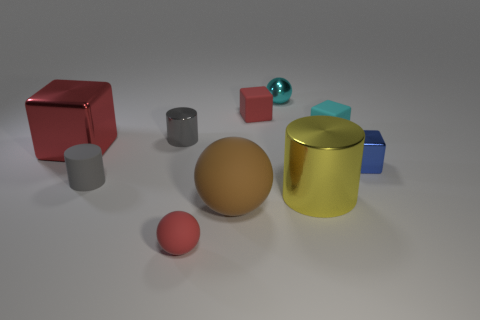Can you describe how the light source in the image affects the appearance of the objects? The light source above the objects creates soft shadows on the ground towards the right. It highlights the metallic sheen on the gold and cyan cylinders and the red cube, while the matte surfaces, like the gray cylinders and the sphere, absorb the light more diffusely, showing less reflection. 